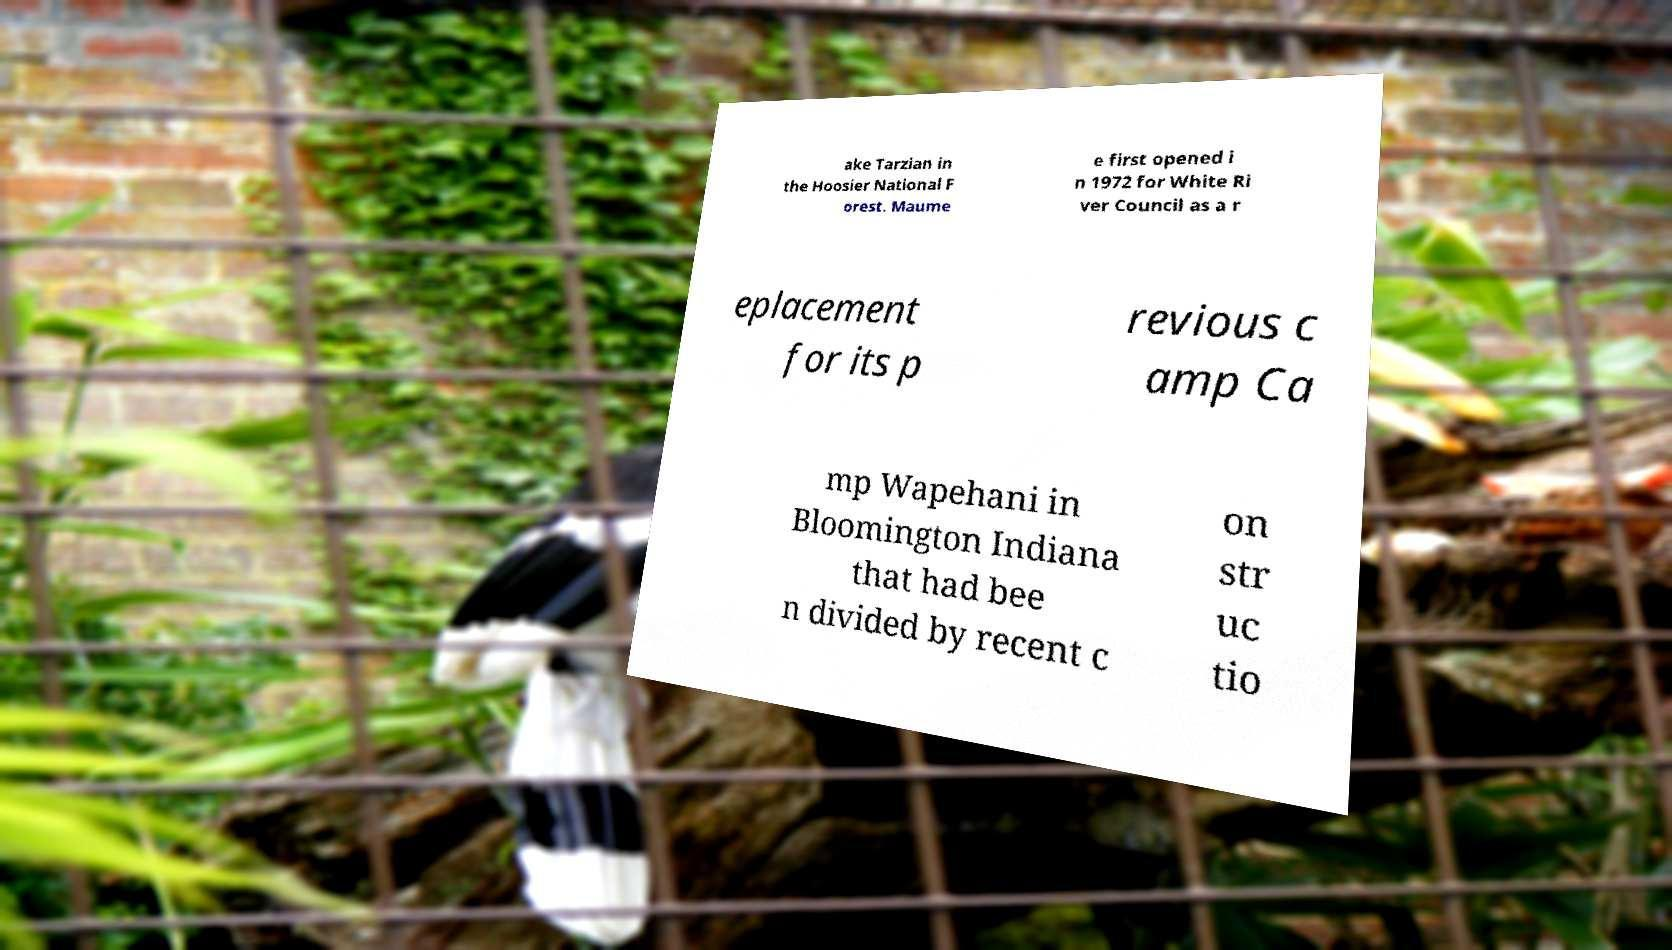Could you extract and type out the text from this image? ake Tarzian in the Hoosier National F orest. Maume e first opened i n 1972 for White Ri ver Council as a r eplacement for its p revious c amp Ca mp Wapehani in Bloomington Indiana that had bee n divided by recent c on str uc tio 